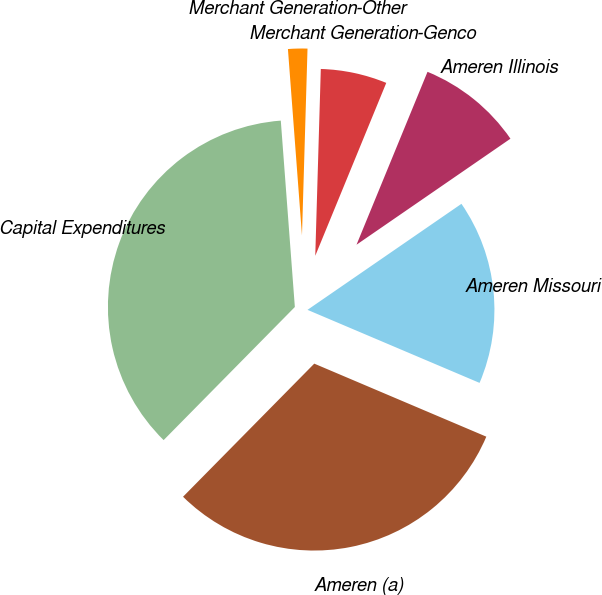Convert chart. <chart><loc_0><loc_0><loc_500><loc_500><pie_chart><fcel>Capital Expenditures<fcel>Ameren (a)<fcel>Ameren Missouri<fcel>Ameren Illinois<fcel>Merchant Generation-Genco<fcel>Merchant Generation-Other<nl><fcel>36.42%<fcel>31.0%<fcel>15.99%<fcel>9.2%<fcel>5.73%<fcel>1.67%<nl></chart> 